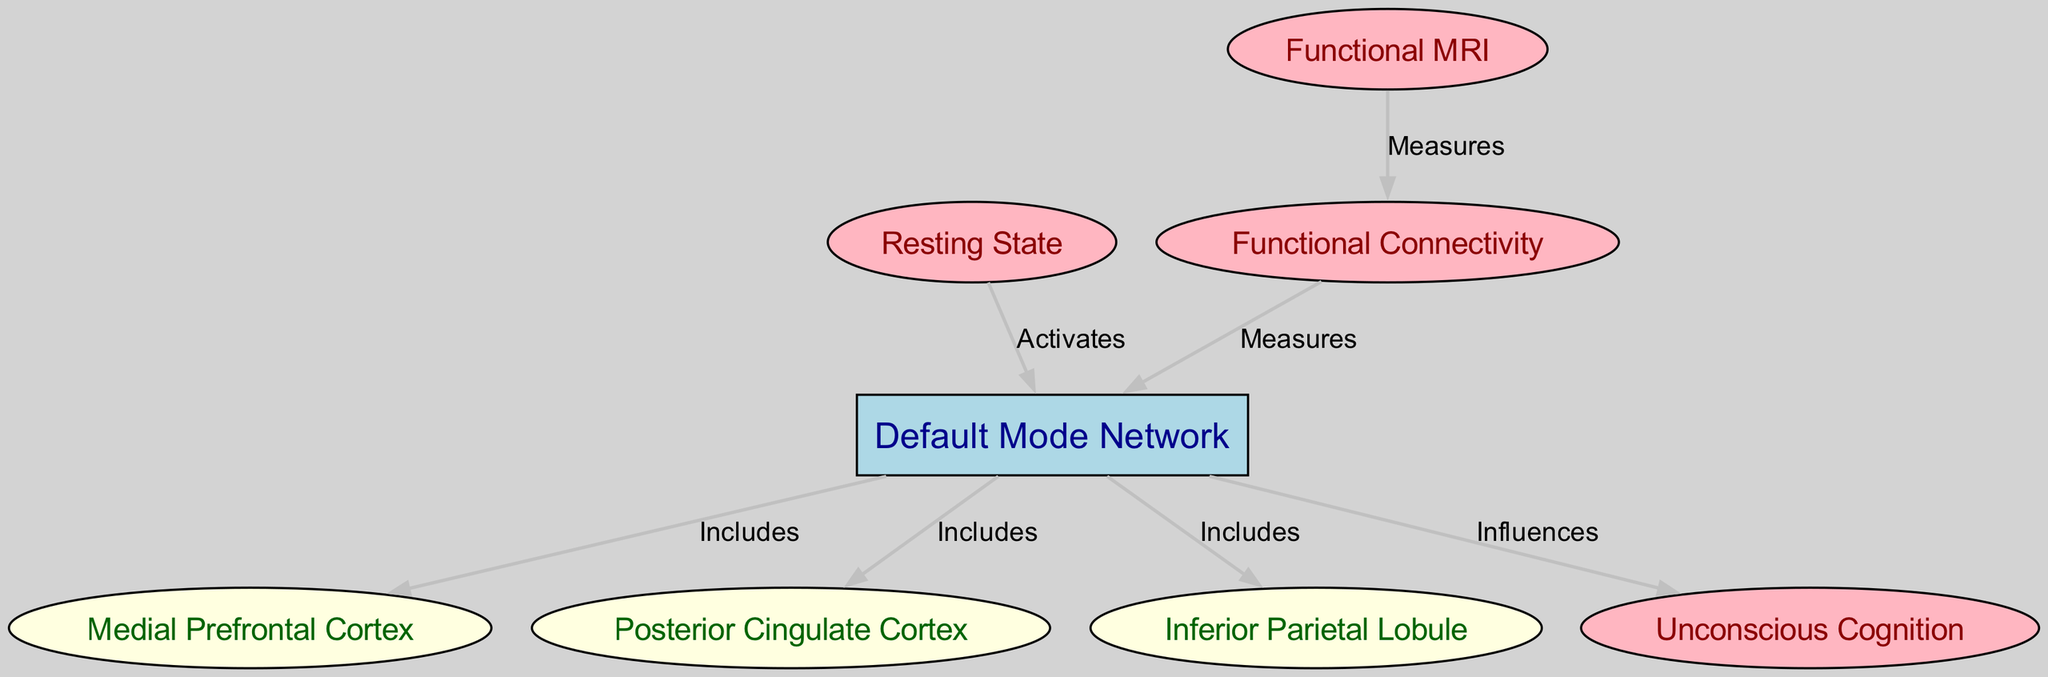What are the components included in the Default Mode Network? The Default Mode Network, or DMN, includes three components: Medial Prefrontal Cortex (MPFC), Posterior Cingulate Cortex (PCC), and Inferior Parietal Lobule (IPL). Each of these nodes is directly connected to the DMN with the label "Includes."
Answer: MPFC, PCC, IPL How many nodes are present in the diagram? By counting the nodes listed, we find a total of eight distinct nodes: DMN, MPFC, PCC, IPL, RS, UC, FC, and fMRI.
Answer: Eight What does the Resting State activate? The Resting State in the diagram has an edge pointing to the Default Mode Network (DMN) with the label "Activates," indicating a direct relationship in this context.
Answer: DMN What influences Unconscious Cognition? The Default Mode Network (DMN) has a direct influence on Unconscious Cognition (UC), as indicated by the edge labeled "Influences" connecting these two nodes.
Answer: Default Mode Network What measures Functional Connectivity? Both Functional Connectivity (FC) and Functional MRI (fMRI) are shown to measure different aspects of the brain’s connectivity and neural activity. Specifically, fMRI measures FC, as indicated by the connecting edge labeled "Measures."
Answer: Functional MRI What two nodes are connected as a result of measuring Functional Connectivity? The edge from fMRI to FC shows that Functional MRI is the tool measured for Functional Connectivity. This demonstrates a direct relationship in the context of the diagram.
Answer: fMRI and Functional Connectivity How many edges connect to the Default Mode Network? When examining the edges surrounding the Default Mode Network, we find four connections: to MPFC, PCC, IPL, and Resting State, as well as one connection to Unconscious Cognition. In total, the DMN connects with four different nodes.
Answer: Four Which node measures Functional Connectivity? The node Functional MRI is specifically linked with Functional Connectivity (FC) by an edge labeled "Measures." This indicates that fMRI is the measure of FC in this context.
Answer: Functional MRI 